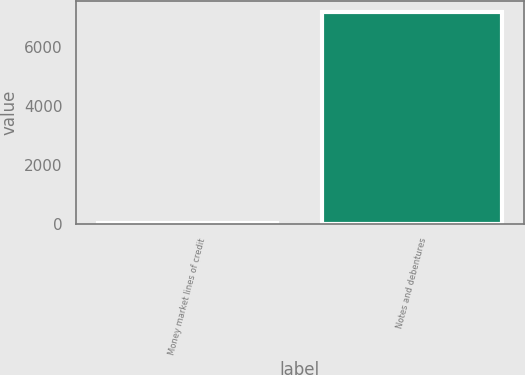Convert chart. <chart><loc_0><loc_0><loc_500><loc_500><bar_chart><fcel>Money market lines of credit<fcel>Notes and debentures<nl><fcel>31<fcel>7185<nl></chart> 